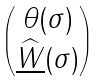Convert formula to latex. <formula><loc_0><loc_0><loc_500><loc_500>\begin{pmatrix} \theta ( \sigma ) \\ \underline { \widehat { W } } ( \sigma ) \end{pmatrix}</formula> 